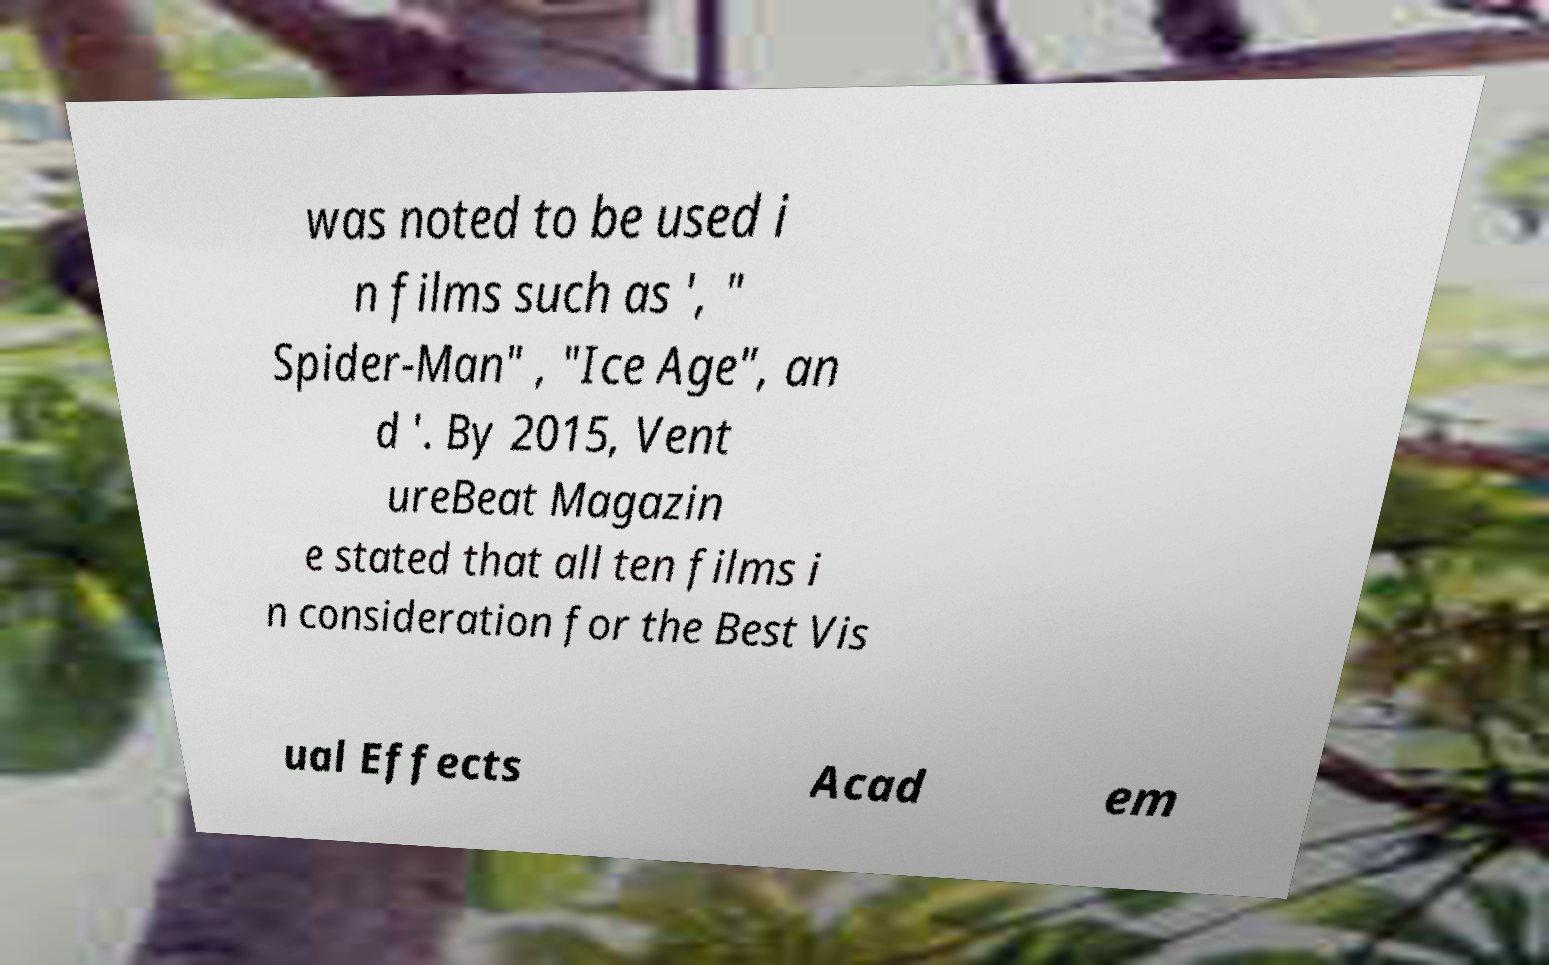Could you extract and type out the text from this image? was noted to be used i n films such as ', " Spider-Man" , "Ice Age", an d '. By 2015, Vent ureBeat Magazin e stated that all ten films i n consideration for the Best Vis ual Effects Acad em 